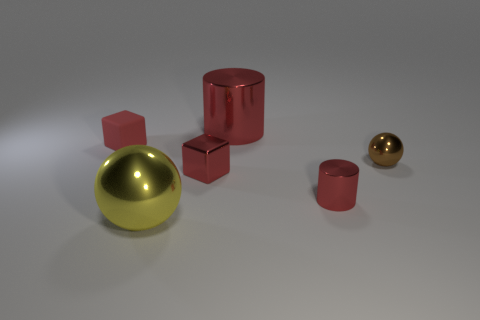What number of other objects are the same color as the big shiny cylinder?
Offer a terse response. 3. The big red object is what shape?
Offer a very short reply. Cylinder. There is a cylinder that is behind the small red thing in front of the small red metal block; what color is it?
Offer a terse response. Red. Does the tiny rubber block have the same color as the cube that is in front of the tiny brown shiny thing?
Ensure brevity in your answer.  Yes. There is a red thing that is behind the brown thing and in front of the large red object; what material is it made of?
Give a very brief answer. Rubber. Are there any cylinders that have the same size as the yellow sphere?
Offer a terse response. Yes. There is another red block that is the same size as the shiny block; what is its material?
Your response must be concise. Rubber. There is a small red shiny cube; what number of tiny metal objects are on the right side of it?
Keep it short and to the point. 2. There is a brown thing on the right side of the yellow thing; is it the same shape as the yellow thing?
Offer a very short reply. Yes. Is there another shiny object that has the same shape as the yellow shiny thing?
Provide a short and direct response. Yes. 